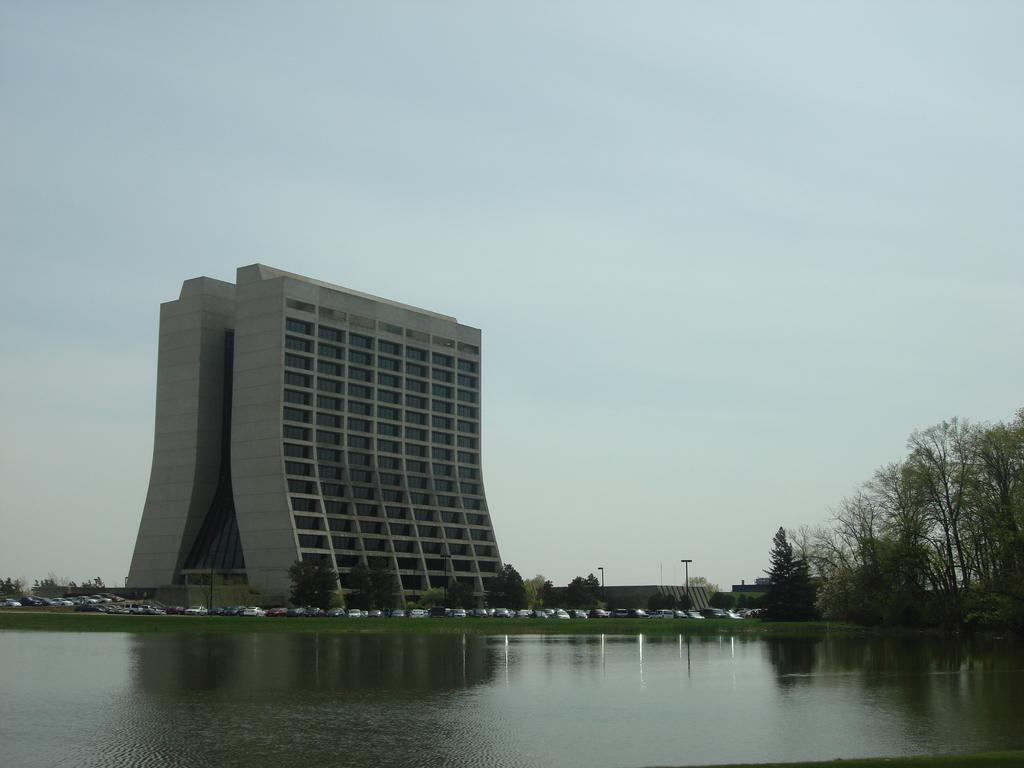What is the primary element visible in the image? There is water in the image. What type of natural elements can be seen in the image? There are trees in the image. What man-made objects are present in the image? There are vehicles in the image. What can be seen in the distance in the image? In the background, there are poles and buildings. What type of milk is being served to the queen in the image? There is no queen or milk present in the image. 